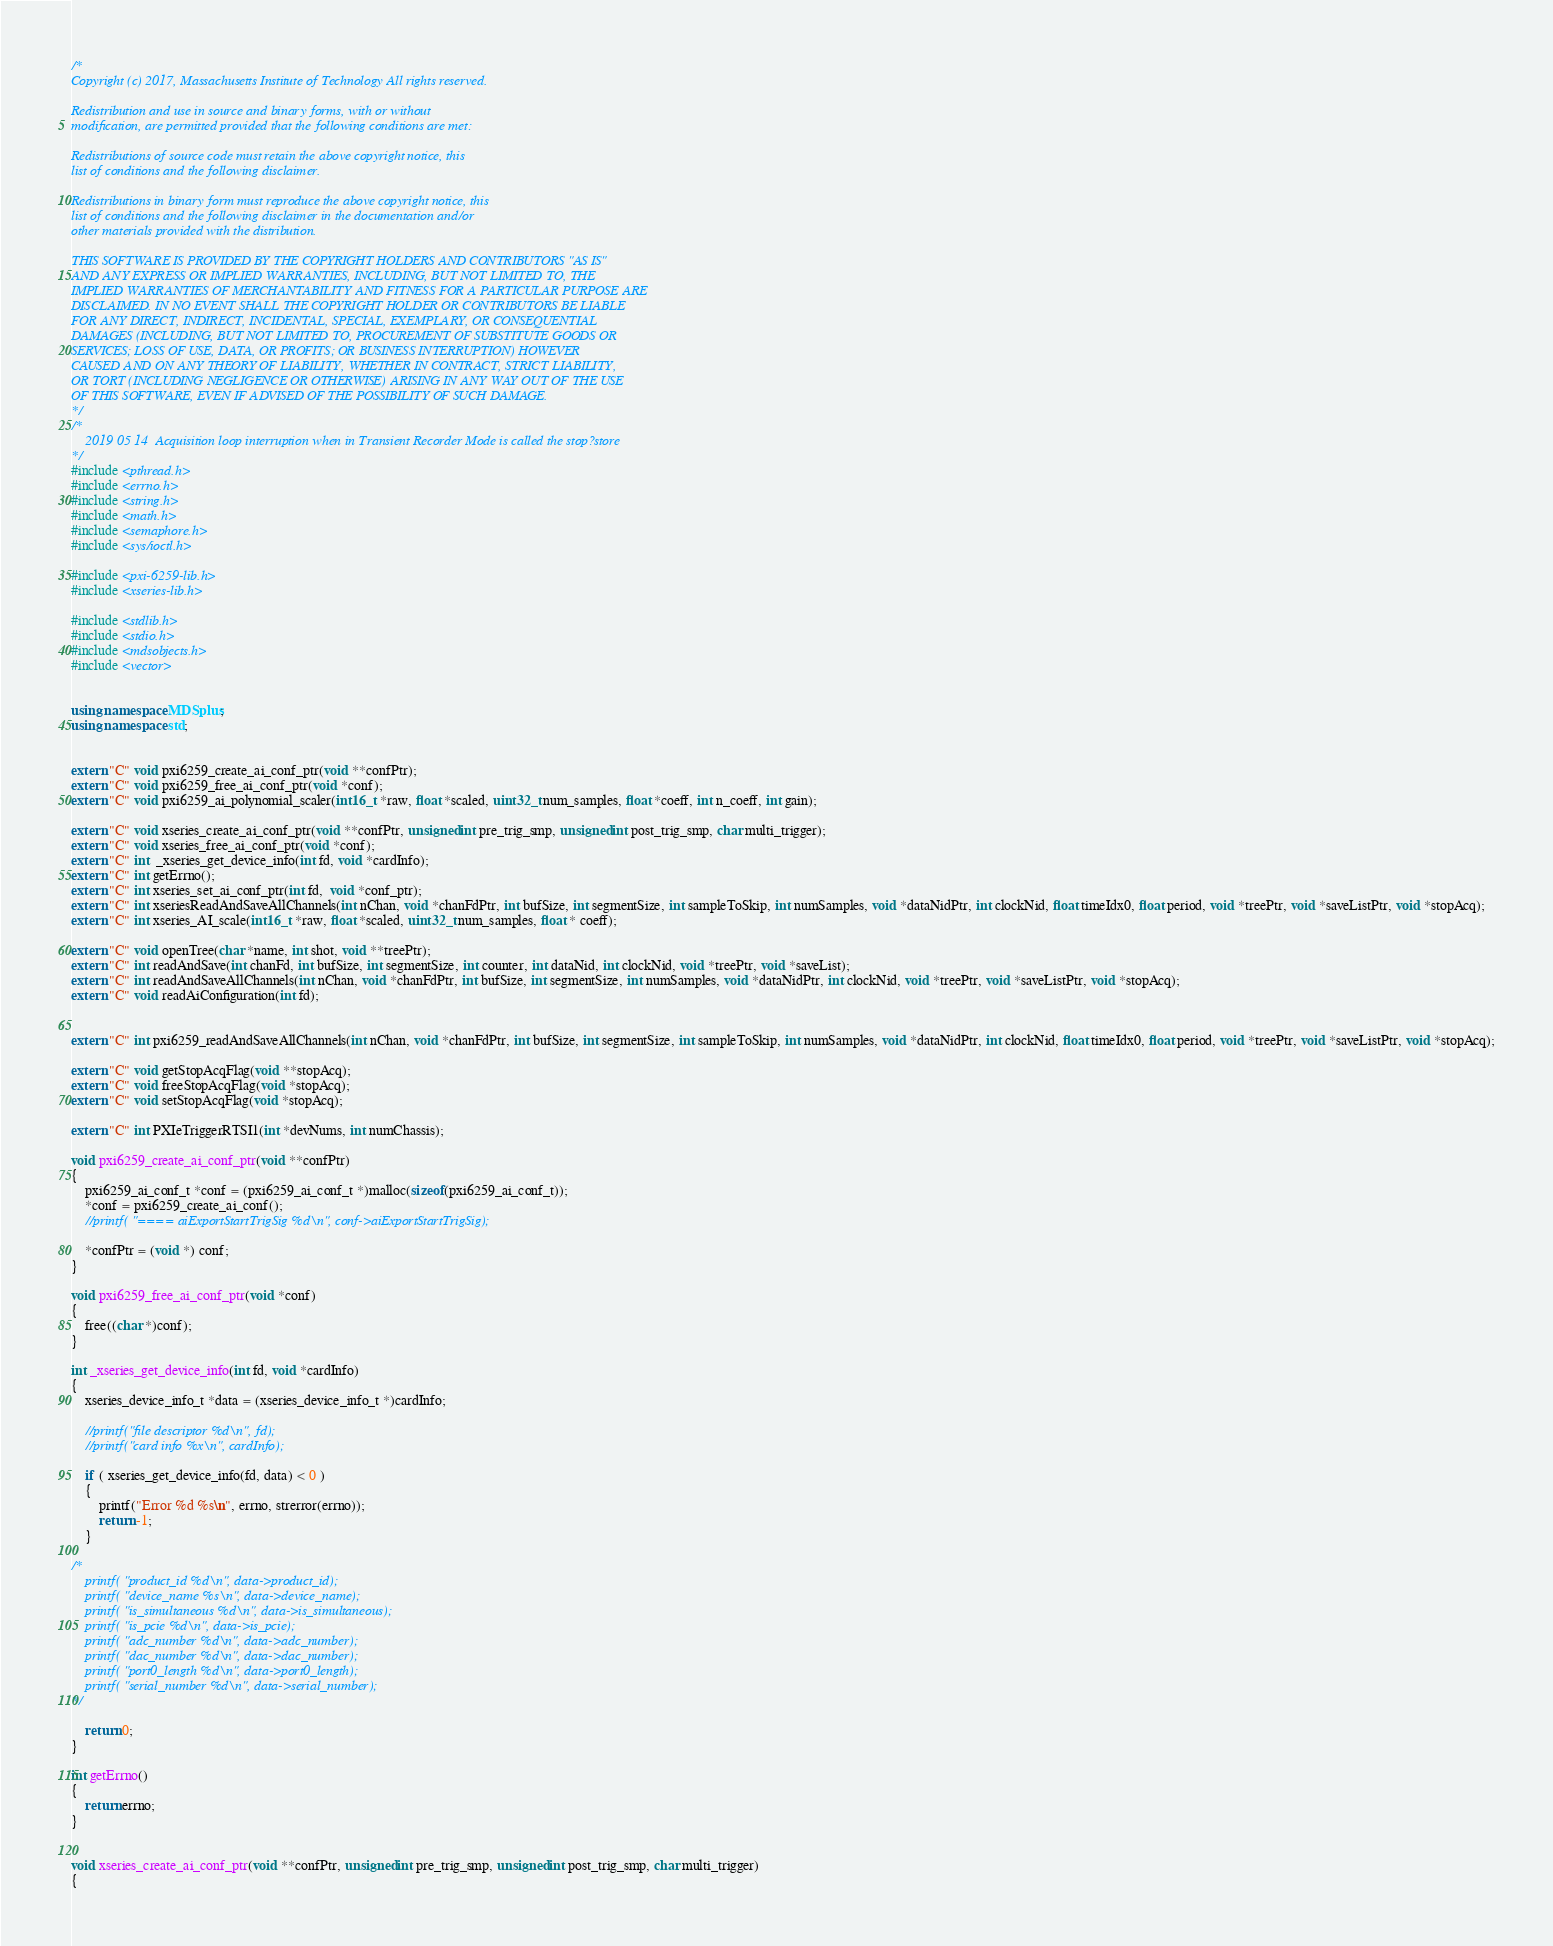Convert code to text. <code><loc_0><loc_0><loc_500><loc_500><_C++_>/*
Copyright (c) 2017, Massachusetts Institute of Technology All rights reserved.

Redistribution and use in source and binary forms, with or without
modification, are permitted provided that the following conditions are met:

Redistributions of source code must retain the above copyright notice, this
list of conditions and the following disclaimer.

Redistributions in binary form must reproduce the above copyright notice, this
list of conditions and the following disclaimer in the documentation and/or
other materials provided with the distribution.

THIS SOFTWARE IS PROVIDED BY THE COPYRIGHT HOLDERS AND CONTRIBUTORS "AS IS"
AND ANY EXPRESS OR IMPLIED WARRANTIES, INCLUDING, BUT NOT LIMITED TO, THE
IMPLIED WARRANTIES OF MERCHANTABILITY AND FITNESS FOR A PARTICULAR PURPOSE ARE
DISCLAIMED. IN NO EVENT SHALL THE COPYRIGHT HOLDER OR CONTRIBUTORS BE LIABLE
FOR ANY DIRECT, INDIRECT, INCIDENTAL, SPECIAL, EXEMPLARY, OR CONSEQUENTIAL
DAMAGES (INCLUDING, BUT NOT LIMITED TO, PROCUREMENT OF SUBSTITUTE GOODS OR
SERVICES; LOSS OF USE, DATA, OR PROFITS; OR BUSINESS INTERRUPTION) HOWEVER
CAUSED AND ON ANY THEORY OF LIABILITY, WHETHER IN CONTRACT, STRICT LIABILITY,
OR TORT (INCLUDING NEGLIGENCE OR OTHERWISE) ARISING IN ANY WAY OUT OF THE USE
OF THIS SOFTWARE, EVEN IF ADVISED OF THE POSSIBILITY OF SUCH DAMAGE.
*/
/*
    2019 05 14  Acquisition loop interruption when in Transient Recorder Mode is called the stop?store 
*/
#include <pthread.h>
#include <errno.h>
#include <string.h>
#include <math.h>
#include <semaphore.h>
#include <sys/ioctl.h>

#include <pxi-6259-lib.h>
#include <xseries-lib.h>

#include <stdlib.h>
#include <stdio.h>
#include <mdsobjects.h>
#include <vector>


using namespace MDSplus;
using namespace std;


extern "C" void pxi6259_create_ai_conf_ptr(void **confPtr);
extern "C" void pxi6259_free_ai_conf_ptr(void *conf);
extern "C" void pxi6259_ai_polynomial_scaler(int16_t *raw, float *scaled, uint32_t num_samples, float *coeff, int n_coeff, int gain);

extern "C" void xseries_create_ai_conf_ptr(void **confPtr, unsigned int pre_trig_smp, unsigned int post_trig_smp, char multi_trigger);
extern "C" void xseries_free_ai_conf_ptr(void *conf);
extern "C" int  _xseries_get_device_info(int fd, void *cardInfo);
extern "C" int getErrno();
extern "C" int xseries_set_ai_conf_ptr(int fd,  void *conf_ptr);
extern "C" int xseriesReadAndSaveAllChannels(int nChan, void *chanFdPtr, int bufSize, int segmentSize, int sampleToSkip, int numSamples, void *dataNidPtr, int clockNid, float timeIdx0, float period, void *treePtr, void *saveListPtr, void *stopAcq);
extern "C" int xseries_AI_scale(int16_t *raw, float *scaled, uint32_t num_samples, float * coeff);

extern "C" void openTree(char *name, int shot, void **treePtr);
extern "C" int readAndSave(int chanFd, int bufSize, int segmentSize, int counter, int dataNid, int clockNid, void *treePtr, void *saveList);
extern "C" int readAndSaveAllChannels(int nChan, void *chanFdPtr, int bufSize, int segmentSize, int numSamples, void *dataNidPtr, int clockNid, void *treePtr, void *saveListPtr, void *stopAcq);
extern "C" void readAiConfiguration(int fd);


extern "C" int pxi6259_readAndSaveAllChannels(int nChan, void *chanFdPtr, int bufSize, int segmentSize, int sampleToSkip, int numSamples, void *dataNidPtr, int clockNid, float timeIdx0, float period, void *treePtr, void *saveListPtr, void *stopAcq);

extern "C" void getStopAcqFlag(void **stopAcq);
extern "C" void freeStopAcqFlag(void *stopAcq);
extern "C" void setStopAcqFlag(void *stopAcq);

extern "C" int PXIeTriggerRTSI1(int *devNums, int numChassis);

void pxi6259_create_ai_conf_ptr(void **confPtr)
{
    pxi6259_ai_conf_t *conf = (pxi6259_ai_conf_t *)malloc(sizeof(pxi6259_ai_conf_t));
    *conf = pxi6259_create_ai_conf();
    //printf( "==== aiExportStartTrigSig %d\n", conf->aiExportStartTrigSig);

    *confPtr = (void *) conf;
}

void pxi6259_free_ai_conf_ptr(void *conf)
{
    free((char *)conf);
}

int _xseries_get_device_info(int fd, void *cardInfo)
{
    xseries_device_info_t *data = (xseries_device_info_t *)cardInfo;

    //printf("file descriptor %d\n", fd);
    //printf("card info %x\n", cardInfo);

    if ( xseries_get_device_info(fd, data) < 0 )
    {
        printf("Error %d %s\n", errno, strerror(errno));
        return -1;
    }

/*
    printf( "product_id %d\n", data->product_id);
    printf( "device_name %s\n", data->device_name);
    printf( "is_simultaneous %d\n", data->is_simultaneous);
    printf( "is_pcie %d\n", data->is_pcie);
    printf( "adc_number %d\n", data->adc_number);
    printf( "dac_number %d\n", data->dac_number);
    printf( "port0_length %d\n", data->port0_length);
    printf( "serial_number %d\n", data->serial_number);
*/

    return 0;
}

int getErrno()
{
    return errno;
}


void xseries_create_ai_conf_ptr(void **confPtr, unsigned int pre_trig_smp, unsigned int post_trig_smp, char multi_trigger)
{</code> 